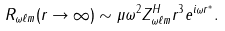Convert formula to latex. <formula><loc_0><loc_0><loc_500><loc_500>R _ { \omega \ell m } ( r \to \infty ) \sim \mu \omega ^ { 2 } Z ^ { H } _ { \omega \ell m } r ^ { 3 } e ^ { i \omega r ^ { * } } .</formula> 